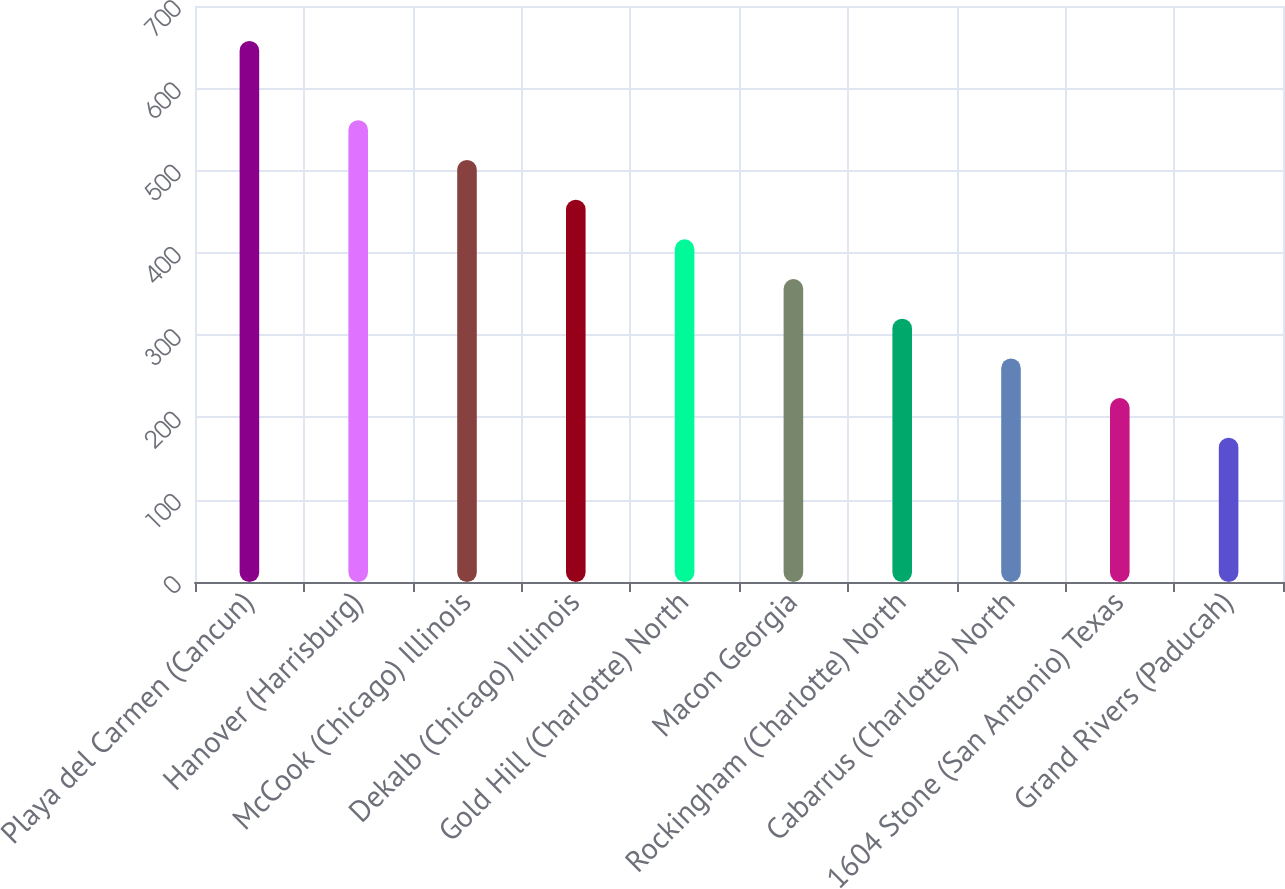Convert chart. <chart><loc_0><loc_0><loc_500><loc_500><bar_chart><fcel>Playa del Carmen (Cancun)<fcel>Hanover (Harrisburg)<fcel>McCook (Chicago) Illinois<fcel>Dekalb (Chicago) Illinois<fcel>Gold Hill (Charlotte) North<fcel>Macon Georgia<fcel>Rockingham (Charlotte) North<fcel>Cabarrus (Charlotte) North<fcel>1604 Stone (San Antonio) Texas<fcel>Grand Rivers (Paducah)<nl><fcel>657.5<fcel>561.2<fcel>512.84<fcel>464.62<fcel>416.4<fcel>368.18<fcel>319.96<fcel>271.74<fcel>223.52<fcel>175.3<nl></chart> 